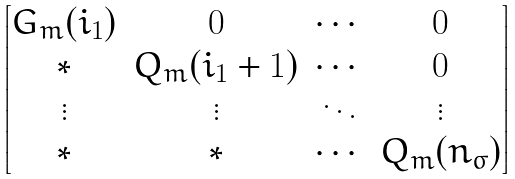<formula> <loc_0><loc_0><loc_500><loc_500>\begin{bmatrix} G _ { m } ( i _ { 1 } ) & 0 & \cdots & 0 \\ \ast & Q _ { m } ( i _ { 1 } + 1 ) & \cdots & 0 \\ \vdots & \vdots & \ddots & \vdots \\ \ast & \ast & \cdots & Q _ { m } ( n _ { \sigma } ) \end{bmatrix}</formula> 